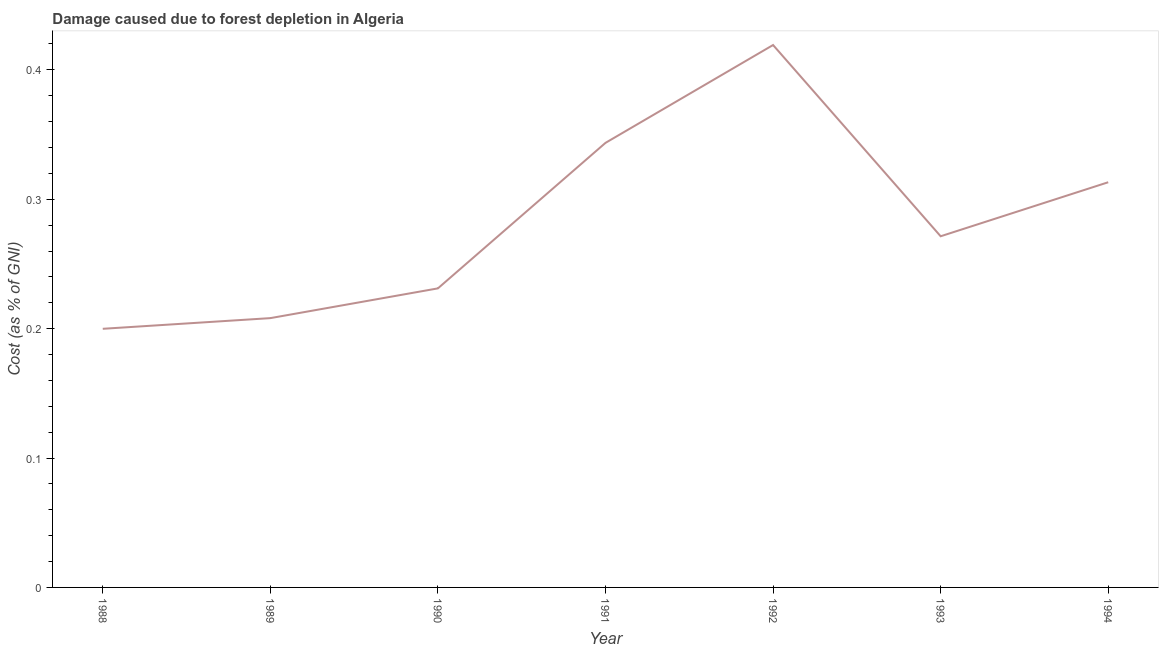What is the damage caused due to forest depletion in 1989?
Offer a very short reply. 0.21. Across all years, what is the maximum damage caused due to forest depletion?
Your answer should be very brief. 0.42. Across all years, what is the minimum damage caused due to forest depletion?
Ensure brevity in your answer.  0.2. In which year was the damage caused due to forest depletion minimum?
Offer a terse response. 1988. What is the sum of the damage caused due to forest depletion?
Give a very brief answer. 1.99. What is the difference between the damage caused due to forest depletion in 1988 and 1993?
Ensure brevity in your answer.  -0.07. What is the average damage caused due to forest depletion per year?
Provide a short and direct response. 0.28. What is the median damage caused due to forest depletion?
Provide a short and direct response. 0.27. In how many years, is the damage caused due to forest depletion greater than 0.30000000000000004 %?
Provide a succinct answer. 3. Do a majority of the years between 1991 and 1992 (inclusive) have damage caused due to forest depletion greater than 0.16 %?
Keep it short and to the point. Yes. What is the ratio of the damage caused due to forest depletion in 1988 to that in 1993?
Make the answer very short. 0.74. Is the difference between the damage caused due to forest depletion in 1991 and 1993 greater than the difference between any two years?
Provide a short and direct response. No. What is the difference between the highest and the second highest damage caused due to forest depletion?
Offer a terse response. 0.08. What is the difference between the highest and the lowest damage caused due to forest depletion?
Your answer should be very brief. 0.22. What is the difference between two consecutive major ticks on the Y-axis?
Ensure brevity in your answer.  0.1. Are the values on the major ticks of Y-axis written in scientific E-notation?
Your response must be concise. No. Does the graph contain any zero values?
Offer a very short reply. No. What is the title of the graph?
Keep it short and to the point. Damage caused due to forest depletion in Algeria. What is the label or title of the X-axis?
Your response must be concise. Year. What is the label or title of the Y-axis?
Ensure brevity in your answer.  Cost (as % of GNI). What is the Cost (as % of GNI) of 1988?
Give a very brief answer. 0.2. What is the Cost (as % of GNI) in 1989?
Make the answer very short. 0.21. What is the Cost (as % of GNI) of 1990?
Your response must be concise. 0.23. What is the Cost (as % of GNI) of 1991?
Your answer should be very brief. 0.34. What is the Cost (as % of GNI) of 1992?
Provide a short and direct response. 0.42. What is the Cost (as % of GNI) in 1993?
Give a very brief answer. 0.27. What is the Cost (as % of GNI) of 1994?
Offer a very short reply. 0.31. What is the difference between the Cost (as % of GNI) in 1988 and 1989?
Keep it short and to the point. -0.01. What is the difference between the Cost (as % of GNI) in 1988 and 1990?
Provide a short and direct response. -0.03. What is the difference between the Cost (as % of GNI) in 1988 and 1991?
Your answer should be compact. -0.14. What is the difference between the Cost (as % of GNI) in 1988 and 1992?
Provide a short and direct response. -0.22. What is the difference between the Cost (as % of GNI) in 1988 and 1993?
Your answer should be compact. -0.07. What is the difference between the Cost (as % of GNI) in 1988 and 1994?
Your answer should be very brief. -0.11. What is the difference between the Cost (as % of GNI) in 1989 and 1990?
Make the answer very short. -0.02. What is the difference between the Cost (as % of GNI) in 1989 and 1991?
Your response must be concise. -0.14. What is the difference between the Cost (as % of GNI) in 1989 and 1992?
Offer a terse response. -0.21. What is the difference between the Cost (as % of GNI) in 1989 and 1993?
Provide a succinct answer. -0.06. What is the difference between the Cost (as % of GNI) in 1989 and 1994?
Keep it short and to the point. -0.11. What is the difference between the Cost (as % of GNI) in 1990 and 1991?
Give a very brief answer. -0.11. What is the difference between the Cost (as % of GNI) in 1990 and 1992?
Offer a very short reply. -0.19. What is the difference between the Cost (as % of GNI) in 1990 and 1993?
Keep it short and to the point. -0.04. What is the difference between the Cost (as % of GNI) in 1990 and 1994?
Your response must be concise. -0.08. What is the difference between the Cost (as % of GNI) in 1991 and 1992?
Keep it short and to the point. -0.08. What is the difference between the Cost (as % of GNI) in 1991 and 1993?
Keep it short and to the point. 0.07. What is the difference between the Cost (as % of GNI) in 1991 and 1994?
Ensure brevity in your answer.  0.03. What is the difference between the Cost (as % of GNI) in 1992 and 1993?
Keep it short and to the point. 0.15. What is the difference between the Cost (as % of GNI) in 1992 and 1994?
Provide a short and direct response. 0.11. What is the difference between the Cost (as % of GNI) in 1993 and 1994?
Provide a short and direct response. -0.04. What is the ratio of the Cost (as % of GNI) in 1988 to that in 1989?
Your answer should be compact. 0.96. What is the ratio of the Cost (as % of GNI) in 1988 to that in 1990?
Make the answer very short. 0.86. What is the ratio of the Cost (as % of GNI) in 1988 to that in 1991?
Your answer should be very brief. 0.58. What is the ratio of the Cost (as % of GNI) in 1988 to that in 1992?
Your answer should be compact. 0.48. What is the ratio of the Cost (as % of GNI) in 1988 to that in 1993?
Make the answer very short. 0.74. What is the ratio of the Cost (as % of GNI) in 1988 to that in 1994?
Offer a terse response. 0.64. What is the ratio of the Cost (as % of GNI) in 1989 to that in 1990?
Your answer should be compact. 0.9. What is the ratio of the Cost (as % of GNI) in 1989 to that in 1991?
Keep it short and to the point. 0.61. What is the ratio of the Cost (as % of GNI) in 1989 to that in 1992?
Offer a terse response. 0.5. What is the ratio of the Cost (as % of GNI) in 1989 to that in 1993?
Your answer should be very brief. 0.77. What is the ratio of the Cost (as % of GNI) in 1989 to that in 1994?
Your response must be concise. 0.67. What is the ratio of the Cost (as % of GNI) in 1990 to that in 1991?
Your response must be concise. 0.67. What is the ratio of the Cost (as % of GNI) in 1990 to that in 1992?
Give a very brief answer. 0.55. What is the ratio of the Cost (as % of GNI) in 1990 to that in 1993?
Provide a short and direct response. 0.85. What is the ratio of the Cost (as % of GNI) in 1990 to that in 1994?
Provide a short and direct response. 0.74. What is the ratio of the Cost (as % of GNI) in 1991 to that in 1992?
Your answer should be very brief. 0.82. What is the ratio of the Cost (as % of GNI) in 1991 to that in 1993?
Your answer should be compact. 1.27. What is the ratio of the Cost (as % of GNI) in 1991 to that in 1994?
Ensure brevity in your answer.  1.1. What is the ratio of the Cost (as % of GNI) in 1992 to that in 1993?
Offer a terse response. 1.54. What is the ratio of the Cost (as % of GNI) in 1992 to that in 1994?
Your response must be concise. 1.34. What is the ratio of the Cost (as % of GNI) in 1993 to that in 1994?
Make the answer very short. 0.87. 